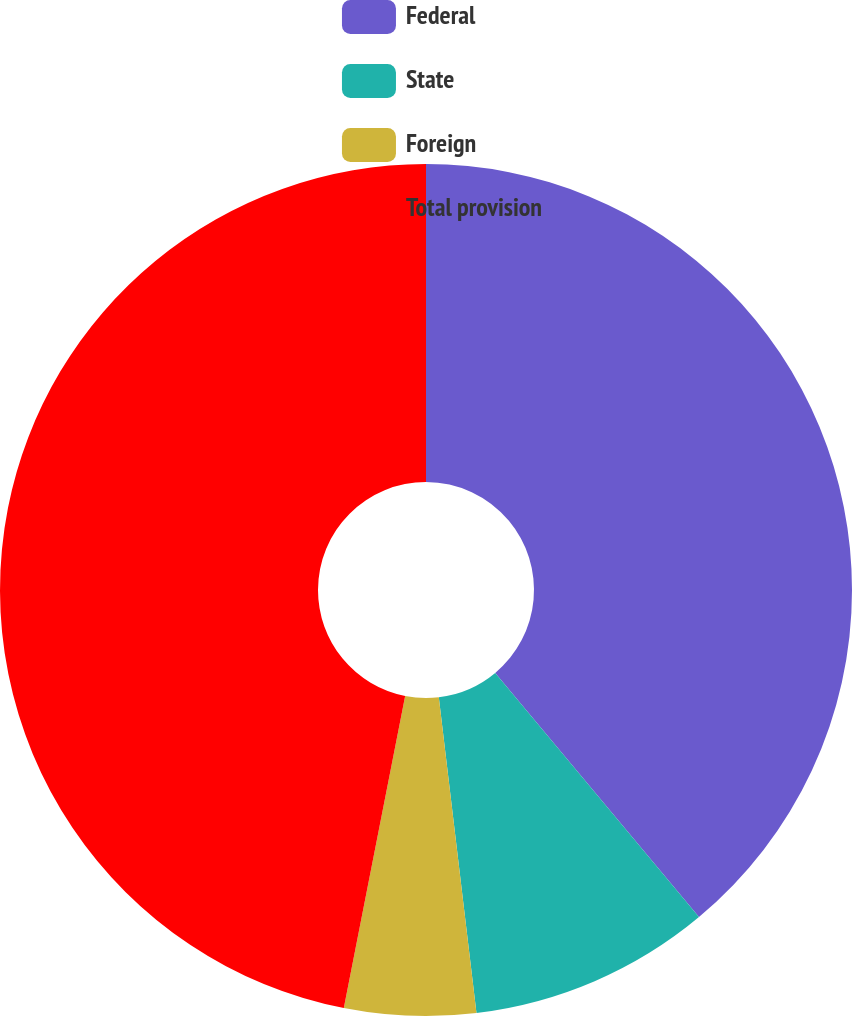Convert chart. <chart><loc_0><loc_0><loc_500><loc_500><pie_chart><fcel>Federal<fcel>State<fcel>Foreign<fcel>Total provision<nl><fcel>38.93%<fcel>9.18%<fcel>4.98%<fcel>46.91%<nl></chart> 